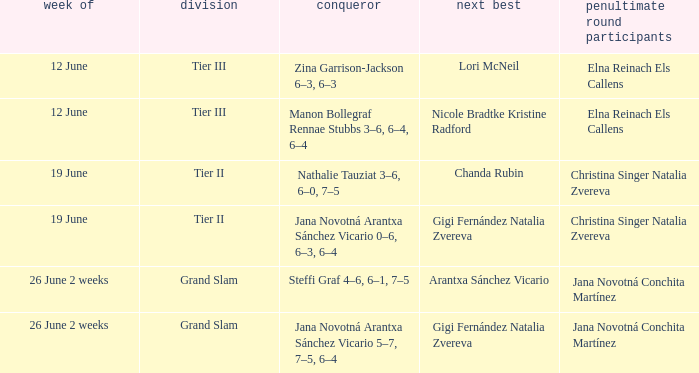Who are the semi-finalists during the week of june 12, with lori mcneil mentioned as the second-place finisher? Elna Reinach Els Callens. 